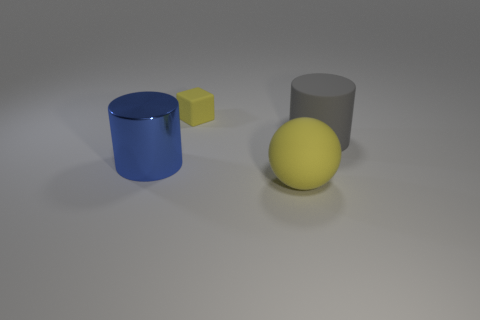There is a yellow object that is made of the same material as the big yellow sphere; what size is it?
Ensure brevity in your answer.  Small. How many large matte things are behind the yellow object that is right of the tiny matte thing?
Provide a succinct answer. 1. There is a thing that is behind the gray matte cylinder; does it have the same size as the blue metallic cylinder?
Your answer should be compact. No. What number of big gray matte objects have the same shape as the large yellow object?
Your response must be concise. 0. The large gray object is what shape?
Your answer should be compact. Cylinder. Are there the same number of matte blocks that are to the right of the large gray matte cylinder and big gray cylinders?
Your answer should be compact. No. Is there any other thing that has the same material as the ball?
Make the answer very short. Yes. Does the yellow thing in front of the cube have the same material as the block?
Offer a very short reply. Yes. Are there fewer large blue things in front of the blue object than large yellow matte spheres?
Keep it short and to the point. Yes. What number of rubber things are cyan balls or gray objects?
Make the answer very short. 1. 